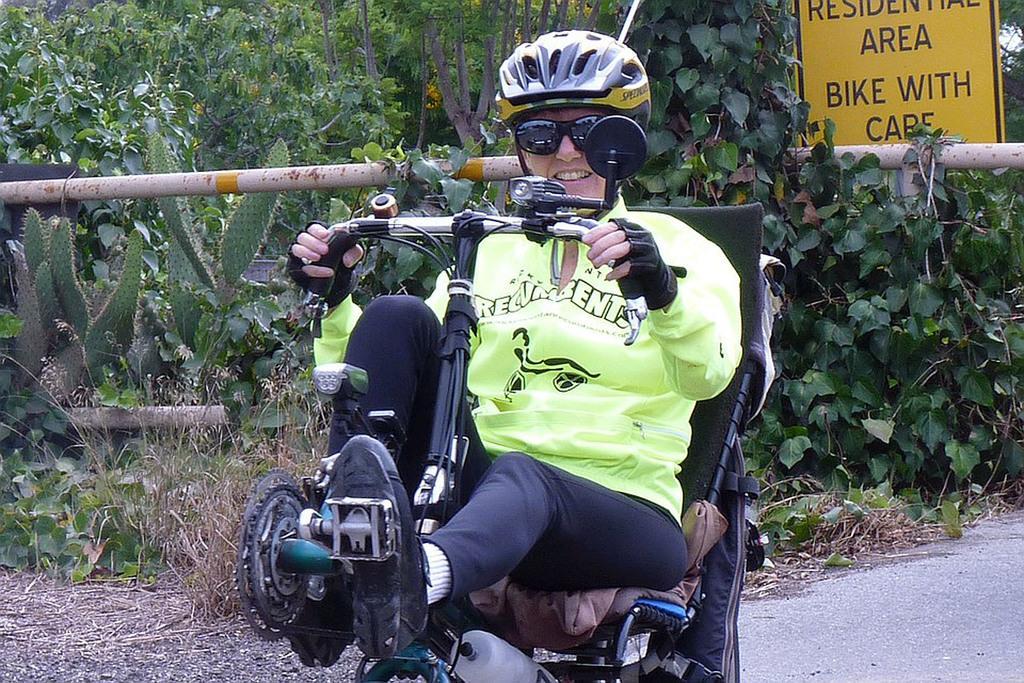Can you describe this image briefly? In the picture a person is riding a vehicle and behind the person there are many plants and trees and in between the plants there is a caution board. 